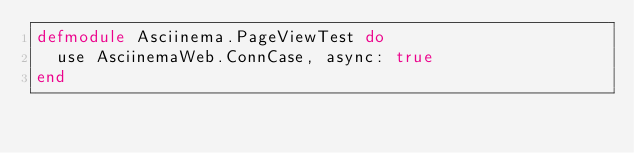<code> <loc_0><loc_0><loc_500><loc_500><_Elixir_>defmodule Asciinema.PageViewTest do
  use AsciinemaWeb.ConnCase, async: true
end
</code> 